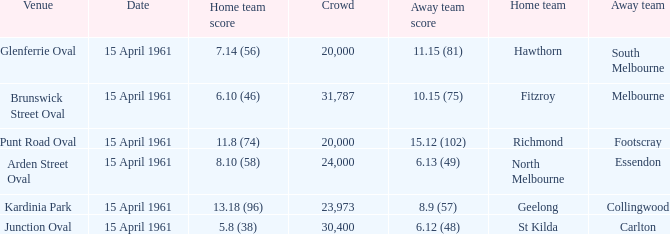What is the average crowd size when Collingwood is the away team? 23973.0. 